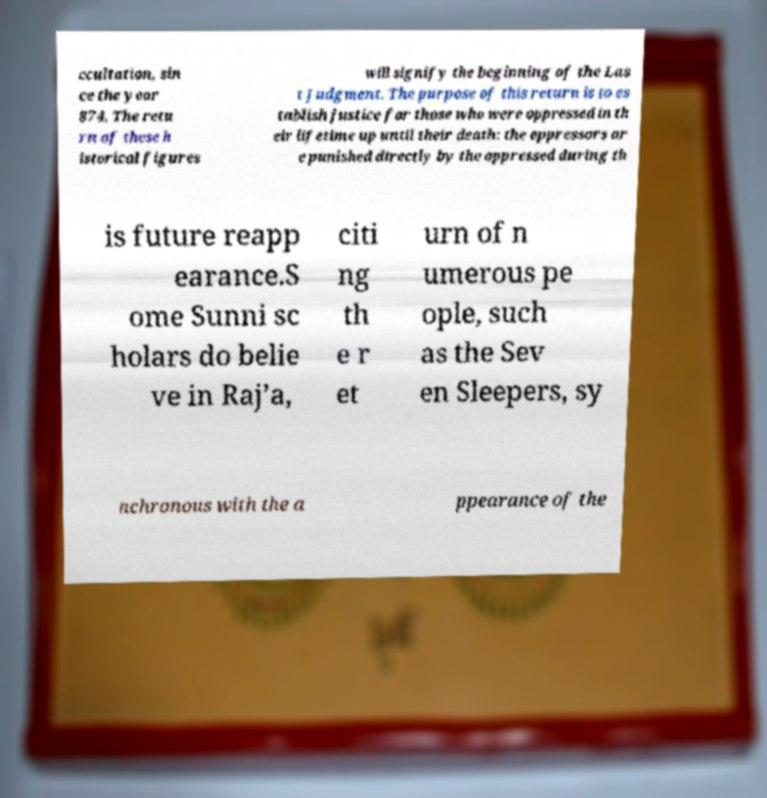Please read and relay the text visible in this image. What does it say? ccultation, sin ce the year 874. The retu rn of these h istorical figures will signify the beginning of the Las t Judgment. The purpose of this return is to es tablish justice for those who were oppressed in th eir lifetime up until their death: the oppressors ar e punished directly by the oppressed during th is future reapp earance.S ome Sunni sc holars do belie ve in Raj’a, citi ng th e r et urn of n umerous pe ople, such as the Sev en Sleepers, sy nchronous with the a ppearance of the 